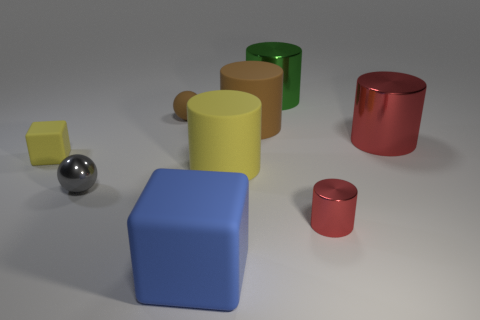Is there any other thing that is the same material as the small yellow block?
Provide a short and direct response. Yes. There is a large yellow thing that is the same shape as the green metal object; what material is it?
Your answer should be compact. Rubber. Are there the same number of large green shiny cylinders that are right of the tiny red metal cylinder and big blue blocks?
Provide a succinct answer. No. How big is the object that is in front of the large yellow rubber cylinder and on the right side of the big green metallic thing?
Your response must be concise. Small. Is there any other thing that is the same color as the tiny block?
Your answer should be very brief. Yes. What is the size of the metallic thing that is left of the large metal thing that is left of the small cylinder?
Keep it short and to the point. Small. There is a object that is in front of the metal ball and to the right of the big yellow matte object; what color is it?
Your answer should be compact. Red. What number of other objects are the same size as the brown cylinder?
Give a very brief answer. 4. There is a blue rubber object; is it the same size as the brown rubber object on the left side of the big rubber cube?
Your answer should be compact. No. What color is the block that is the same size as the green metallic object?
Provide a succinct answer. Blue. 